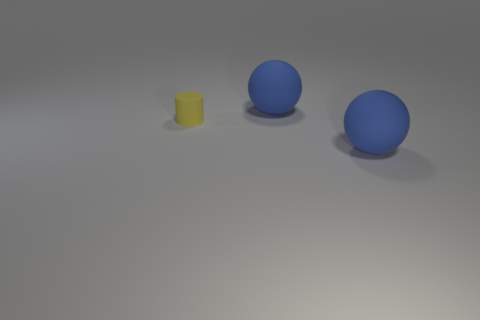Add 2 yellow cylinders. How many objects exist? 5 Subtract all cylinders. How many objects are left? 2 Add 2 rubber cylinders. How many rubber cylinders are left? 3 Add 3 blue things. How many blue things exist? 5 Subtract 0 red spheres. How many objects are left? 3 Subtract all brown balls. Subtract all cyan cylinders. How many balls are left? 2 Subtract all tiny yellow matte cylinders. Subtract all blue matte balls. How many objects are left? 0 